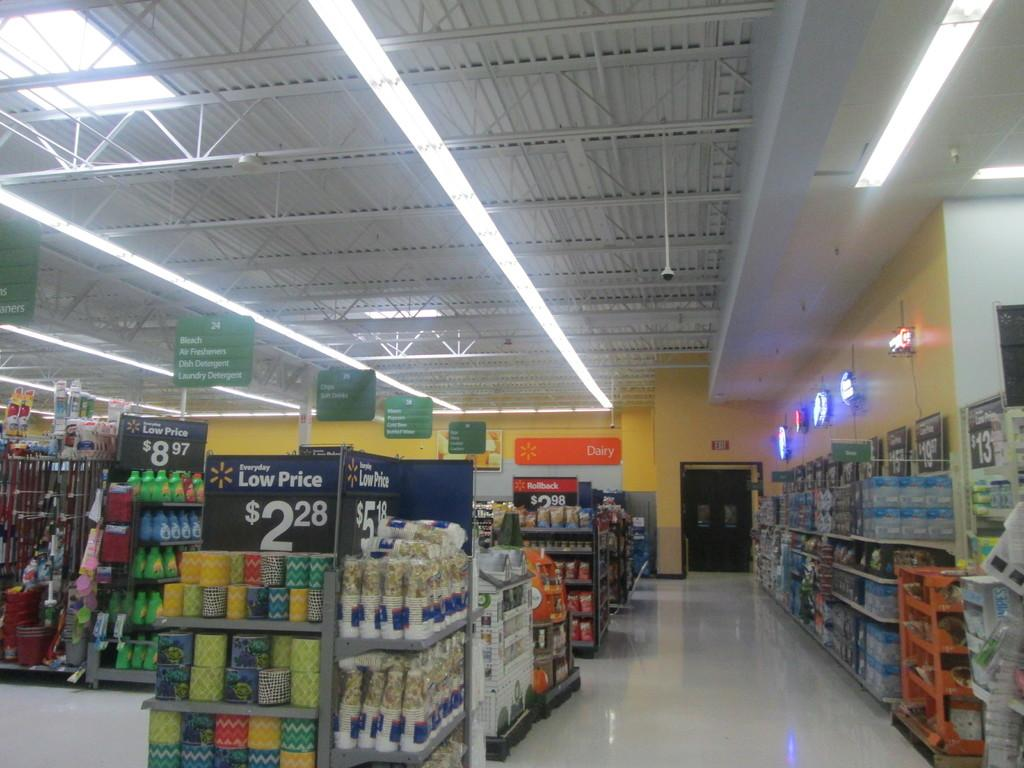<image>
Relay a brief, clear account of the picture shown. An endcap advertises the low price of $2.28. 